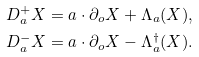Convert formula to latex. <formula><loc_0><loc_0><loc_500><loc_500>D _ { a } ^ { + } X & = a \cdot \partial _ { o } X + \Lambda _ { a } ( X ) , \\ D _ { a } ^ { - } X & = a \cdot \partial _ { o } X - \Lambda _ { a } ^ { \dagger } ( X ) .</formula> 